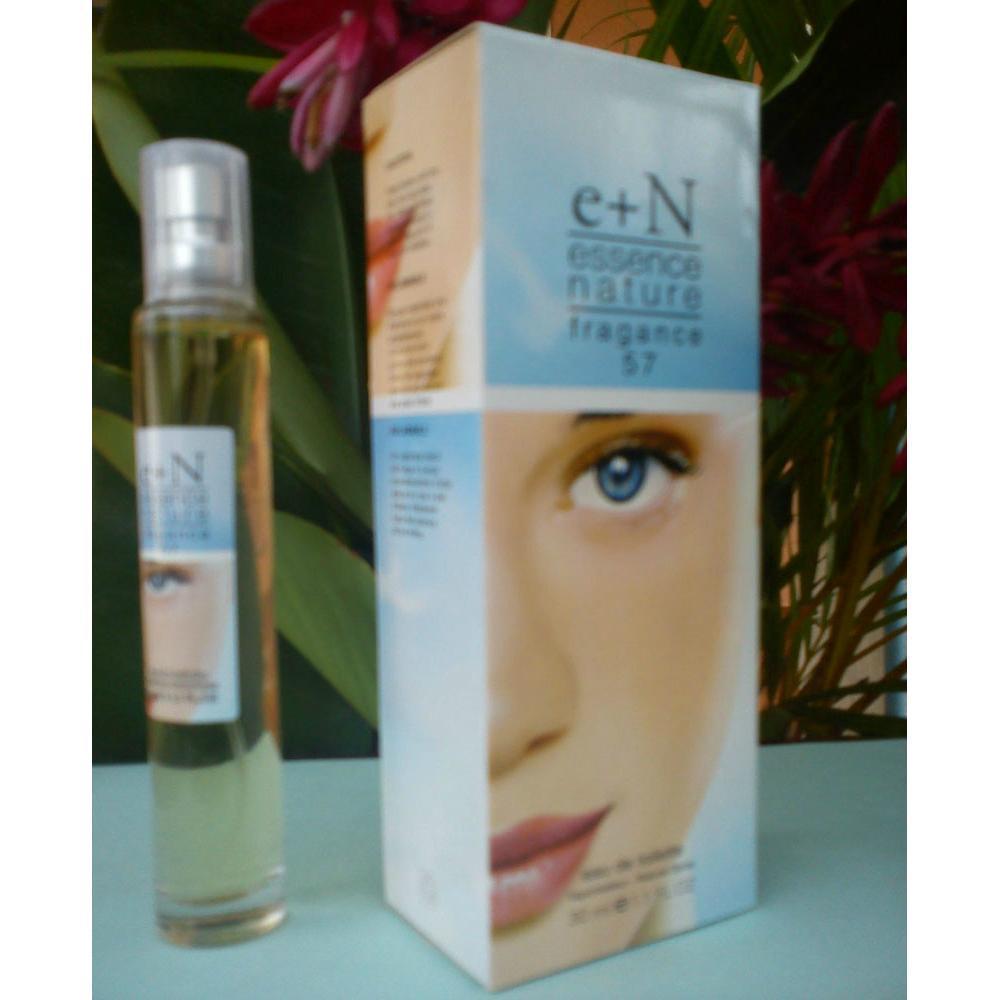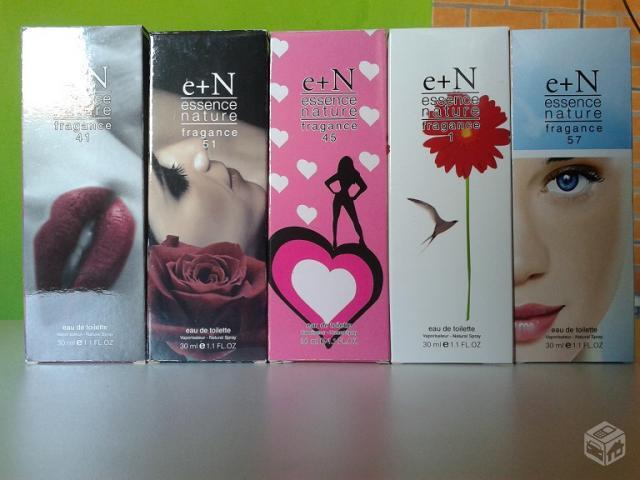The first image is the image on the left, the second image is the image on the right. Evaluate the accuracy of this statement regarding the images: "An image shows a single row of at least five upright boxes standing on a shiny surface.". Is it true? Answer yes or no. Yes. The first image is the image on the left, the second image is the image on the right. Examine the images to the left and right. Is the description "The lone box of 'essence of nature' features half of a female face." accurate? Answer yes or no. Yes. 